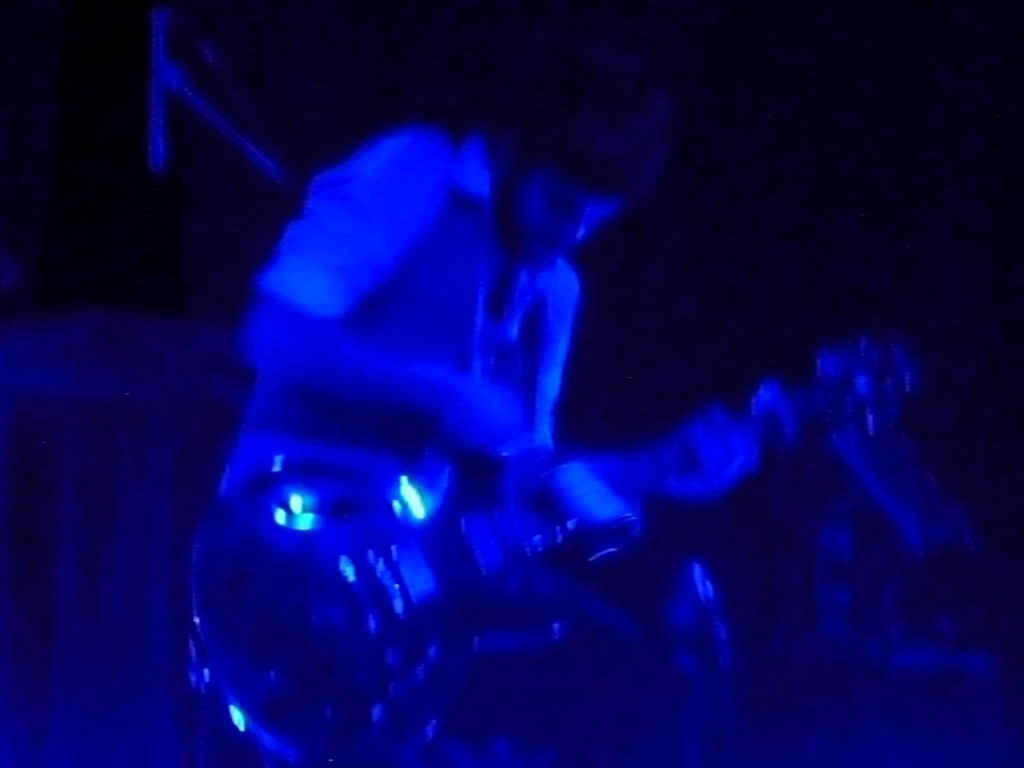Does the image have proper exposure? Option B is correct; the image does not have proper exposure. The scene is overwhelmingly dominated by blue, creating a monochromatic appearance that obscures details. This could be the result of low-light conditions or specific lighting used during a performance, which has caused an underexposure in the photograph. 